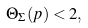<formula> <loc_0><loc_0><loc_500><loc_500>\Theta _ { \Sigma } ( p ) < 2 ,</formula> 